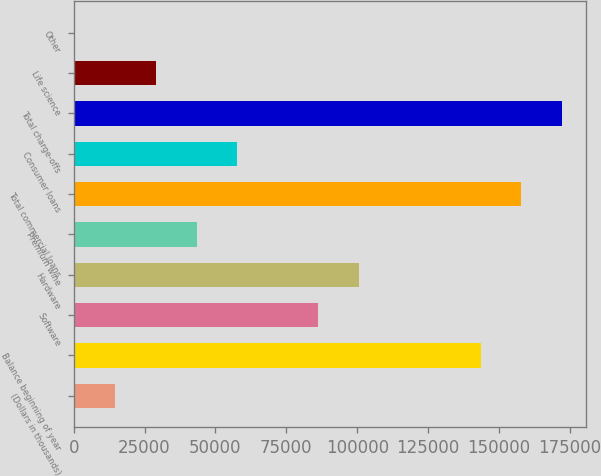Convert chart to OTSL. <chart><loc_0><loc_0><loc_500><loc_500><bar_chart><fcel>(Dollars in thousands)<fcel>Balance beginning of year<fcel>Software<fcel>Hardware<fcel>Premium wine<fcel>Total commercial loans<fcel>Consumer loans<fcel>Total charge-offs<fcel>Life science<fcel>Other<nl><fcel>14728.7<fcel>143570<fcel>86307.2<fcel>100623<fcel>43360.1<fcel>157886<fcel>57675.8<fcel>172201<fcel>29044.4<fcel>413<nl></chart> 